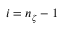Convert formula to latex. <formula><loc_0><loc_0><loc_500><loc_500>i = n _ { \zeta } - 1</formula> 